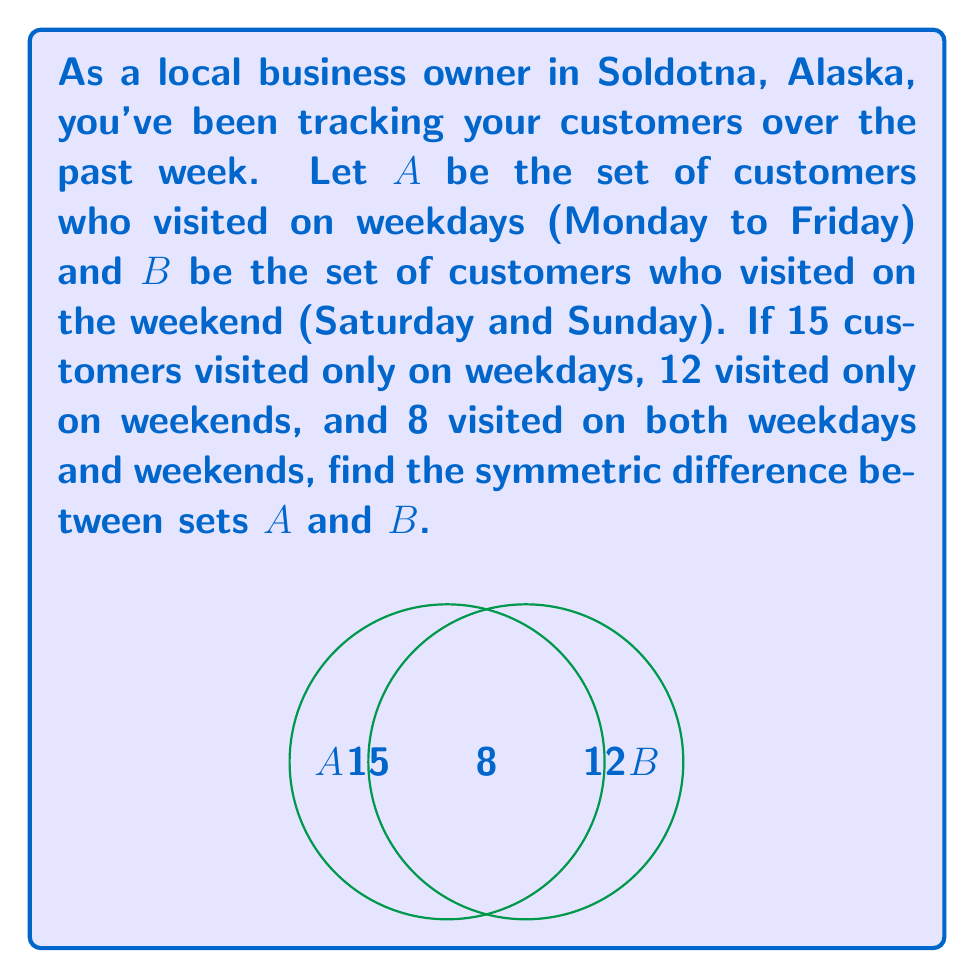Solve this math problem. Let's approach this step-by-step:

1) First, recall that the symmetric difference of two sets A and B, denoted as $A \triangle B$, is defined as:

   $A \triangle B = (A \setminus B) \cup (B \setminus A)$

   This means it includes elements that are in either A or B, but not in both.

2) From the given information:
   - 15 customers visited only on weekdays: these are in A but not in B
   - 12 customers visited only on weekends: these are in B but not in A
   - 8 customers visited on both weekdays and weekends: these are in the intersection of A and B

3) The symmetric difference will include:
   - The 15 customers who visited only on weekdays
   - The 12 customers who visited only on weekends

4) It will not include the 8 customers who visited on both weekdays and weekends.

5) Therefore, we can calculate the symmetric difference by adding:
   
   $|A \triangle B| = 15 + 12 = 27$

Thus, the symmetric difference contains 27 customers.
Answer: 27 customers 